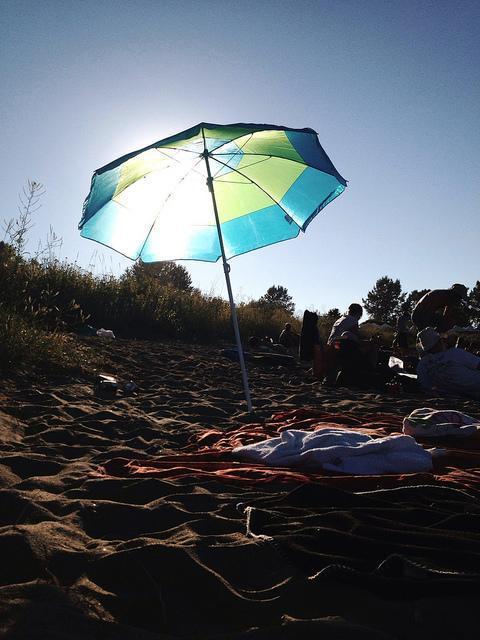How many beach towels are laying on the sand?
Give a very brief answer. 2. How many dogs are in the picture?
Give a very brief answer. 0. 